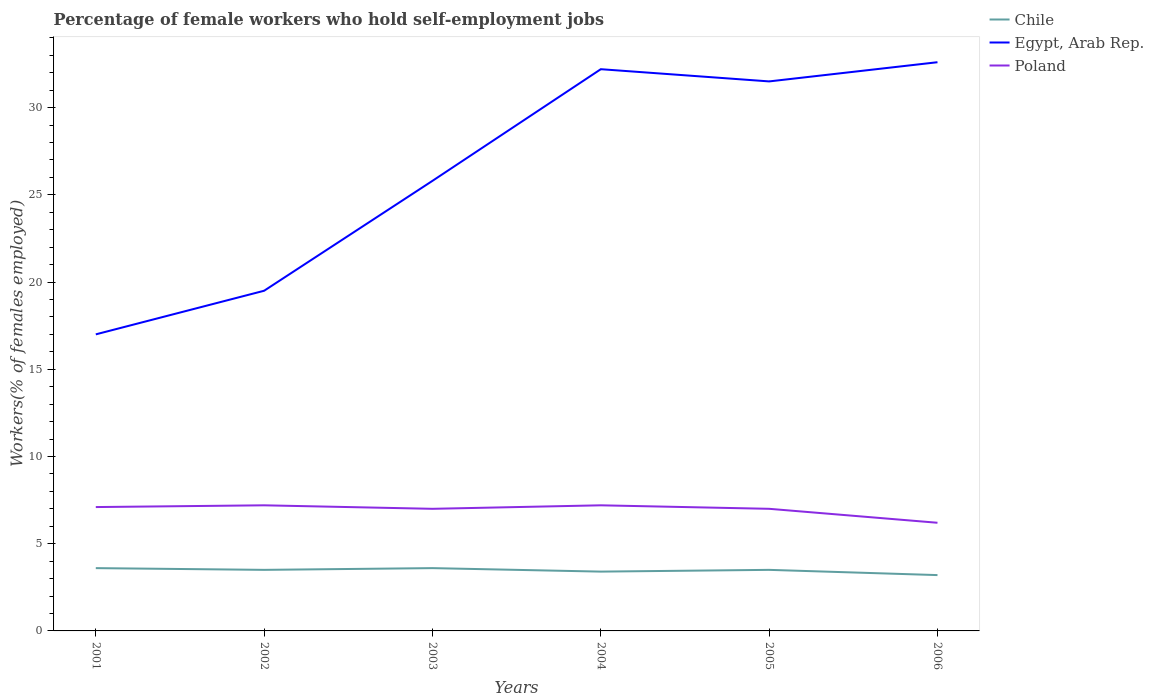How many different coloured lines are there?
Ensure brevity in your answer.  3. What is the total percentage of self-employed female workers in Egypt, Arab Rep. in the graph?
Ensure brevity in your answer.  -6.3. What is the difference between the highest and the second highest percentage of self-employed female workers in Egypt, Arab Rep.?
Provide a succinct answer. 15.6. Is the percentage of self-employed female workers in Poland strictly greater than the percentage of self-employed female workers in Chile over the years?
Give a very brief answer. No. How many lines are there?
Offer a terse response. 3. How many years are there in the graph?
Your answer should be very brief. 6. Are the values on the major ticks of Y-axis written in scientific E-notation?
Your answer should be very brief. No. Does the graph contain any zero values?
Offer a terse response. No. How are the legend labels stacked?
Your response must be concise. Vertical. What is the title of the graph?
Your answer should be compact. Percentage of female workers who hold self-employment jobs. Does "Czech Republic" appear as one of the legend labels in the graph?
Keep it short and to the point. No. What is the label or title of the Y-axis?
Your answer should be very brief. Workers(% of females employed). What is the Workers(% of females employed) in Chile in 2001?
Offer a terse response. 3.6. What is the Workers(% of females employed) of Egypt, Arab Rep. in 2001?
Give a very brief answer. 17. What is the Workers(% of females employed) of Poland in 2001?
Provide a succinct answer. 7.1. What is the Workers(% of females employed) of Chile in 2002?
Offer a very short reply. 3.5. What is the Workers(% of females employed) of Poland in 2002?
Provide a short and direct response. 7.2. What is the Workers(% of females employed) in Chile in 2003?
Your response must be concise. 3.6. What is the Workers(% of females employed) in Egypt, Arab Rep. in 2003?
Give a very brief answer. 25.8. What is the Workers(% of females employed) of Poland in 2003?
Offer a terse response. 7. What is the Workers(% of females employed) in Chile in 2004?
Your response must be concise. 3.4. What is the Workers(% of females employed) in Egypt, Arab Rep. in 2004?
Your answer should be very brief. 32.2. What is the Workers(% of females employed) of Poland in 2004?
Provide a short and direct response. 7.2. What is the Workers(% of females employed) in Chile in 2005?
Offer a very short reply. 3.5. What is the Workers(% of females employed) in Egypt, Arab Rep. in 2005?
Give a very brief answer. 31.5. What is the Workers(% of females employed) of Poland in 2005?
Your answer should be very brief. 7. What is the Workers(% of females employed) in Chile in 2006?
Your answer should be compact. 3.2. What is the Workers(% of females employed) of Egypt, Arab Rep. in 2006?
Your response must be concise. 32.6. What is the Workers(% of females employed) in Poland in 2006?
Make the answer very short. 6.2. Across all years, what is the maximum Workers(% of females employed) in Chile?
Make the answer very short. 3.6. Across all years, what is the maximum Workers(% of females employed) of Egypt, Arab Rep.?
Your answer should be very brief. 32.6. Across all years, what is the maximum Workers(% of females employed) in Poland?
Ensure brevity in your answer.  7.2. Across all years, what is the minimum Workers(% of females employed) in Chile?
Provide a succinct answer. 3.2. Across all years, what is the minimum Workers(% of females employed) in Egypt, Arab Rep.?
Give a very brief answer. 17. Across all years, what is the minimum Workers(% of females employed) of Poland?
Give a very brief answer. 6.2. What is the total Workers(% of females employed) in Chile in the graph?
Give a very brief answer. 20.8. What is the total Workers(% of females employed) in Egypt, Arab Rep. in the graph?
Give a very brief answer. 158.6. What is the total Workers(% of females employed) of Poland in the graph?
Offer a terse response. 41.7. What is the difference between the Workers(% of females employed) of Egypt, Arab Rep. in 2001 and that in 2004?
Your answer should be compact. -15.2. What is the difference between the Workers(% of females employed) of Poland in 2001 and that in 2004?
Keep it short and to the point. -0.1. What is the difference between the Workers(% of females employed) of Egypt, Arab Rep. in 2001 and that in 2005?
Provide a short and direct response. -14.5. What is the difference between the Workers(% of females employed) of Chile in 2001 and that in 2006?
Make the answer very short. 0.4. What is the difference between the Workers(% of females employed) of Egypt, Arab Rep. in 2001 and that in 2006?
Your answer should be compact. -15.6. What is the difference between the Workers(% of females employed) of Poland in 2001 and that in 2006?
Your answer should be very brief. 0.9. What is the difference between the Workers(% of females employed) in Chile in 2002 and that in 2003?
Provide a short and direct response. -0.1. What is the difference between the Workers(% of females employed) in Poland in 2002 and that in 2003?
Your response must be concise. 0.2. What is the difference between the Workers(% of females employed) in Chile in 2002 and that in 2004?
Your response must be concise. 0.1. What is the difference between the Workers(% of females employed) of Egypt, Arab Rep. in 2002 and that in 2004?
Give a very brief answer. -12.7. What is the difference between the Workers(% of females employed) of Poland in 2002 and that in 2006?
Give a very brief answer. 1. What is the difference between the Workers(% of females employed) in Poland in 2003 and that in 2004?
Your response must be concise. -0.2. What is the difference between the Workers(% of females employed) of Egypt, Arab Rep. in 2003 and that in 2005?
Provide a short and direct response. -5.7. What is the difference between the Workers(% of females employed) of Chile in 2003 and that in 2006?
Offer a terse response. 0.4. What is the difference between the Workers(% of females employed) in Poland in 2003 and that in 2006?
Your answer should be compact. 0.8. What is the difference between the Workers(% of females employed) in Poland in 2004 and that in 2005?
Offer a very short reply. 0.2. What is the difference between the Workers(% of females employed) of Egypt, Arab Rep. in 2004 and that in 2006?
Ensure brevity in your answer.  -0.4. What is the difference between the Workers(% of females employed) in Poland in 2004 and that in 2006?
Keep it short and to the point. 1. What is the difference between the Workers(% of females employed) in Poland in 2005 and that in 2006?
Your answer should be very brief. 0.8. What is the difference between the Workers(% of females employed) of Chile in 2001 and the Workers(% of females employed) of Egypt, Arab Rep. in 2002?
Provide a short and direct response. -15.9. What is the difference between the Workers(% of females employed) of Egypt, Arab Rep. in 2001 and the Workers(% of females employed) of Poland in 2002?
Your answer should be very brief. 9.8. What is the difference between the Workers(% of females employed) of Chile in 2001 and the Workers(% of females employed) of Egypt, Arab Rep. in 2003?
Make the answer very short. -22.2. What is the difference between the Workers(% of females employed) of Chile in 2001 and the Workers(% of females employed) of Egypt, Arab Rep. in 2004?
Make the answer very short. -28.6. What is the difference between the Workers(% of females employed) of Egypt, Arab Rep. in 2001 and the Workers(% of females employed) of Poland in 2004?
Keep it short and to the point. 9.8. What is the difference between the Workers(% of females employed) of Chile in 2001 and the Workers(% of females employed) of Egypt, Arab Rep. in 2005?
Your answer should be compact. -27.9. What is the difference between the Workers(% of females employed) of Chile in 2001 and the Workers(% of females employed) of Poland in 2005?
Provide a succinct answer. -3.4. What is the difference between the Workers(% of females employed) of Egypt, Arab Rep. in 2001 and the Workers(% of females employed) of Poland in 2005?
Your answer should be compact. 10. What is the difference between the Workers(% of females employed) in Chile in 2001 and the Workers(% of females employed) in Egypt, Arab Rep. in 2006?
Make the answer very short. -29. What is the difference between the Workers(% of females employed) in Egypt, Arab Rep. in 2001 and the Workers(% of females employed) in Poland in 2006?
Your answer should be very brief. 10.8. What is the difference between the Workers(% of females employed) in Chile in 2002 and the Workers(% of females employed) in Egypt, Arab Rep. in 2003?
Give a very brief answer. -22.3. What is the difference between the Workers(% of females employed) of Chile in 2002 and the Workers(% of females employed) of Poland in 2003?
Make the answer very short. -3.5. What is the difference between the Workers(% of females employed) in Egypt, Arab Rep. in 2002 and the Workers(% of females employed) in Poland in 2003?
Offer a terse response. 12.5. What is the difference between the Workers(% of females employed) of Chile in 2002 and the Workers(% of females employed) of Egypt, Arab Rep. in 2004?
Offer a terse response. -28.7. What is the difference between the Workers(% of females employed) in Egypt, Arab Rep. in 2002 and the Workers(% of females employed) in Poland in 2004?
Your response must be concise. 12.3. What is the difference between the Workers(% of females employed) of Chile in 2002 and the Workers(% of females employed) of Egypt, Arab Rep. in 2005?
Your response must be concise. -28. What is the difference between the Workers(% of females employed) of Chile in 2002 and the Workers(% of females employed) of Poland in 2005?
Your answer should be compact. -3.5. What is the difference between the Workers(% of females employed) in Egypt, Arab Rep. in 2002 and the Workers(% of females employed) in Poland in 2005?
Make the answer very short. 12.5. What is the difference between the Workers(% of females employed) of Chile in 2002 and the Workers(% of females employed) of Egypt, Arab Rep. in 2006?
Provide a short and direct response. -29.1. What is the difference between the Workers(% of females employed) of Chile in 2002 and the Workers(% of females employed) of Poland in 2006?
Provide a short and direct response. -2.7. What is the difference between the Workers(% of females employed) in Chile in 2003 and the Workers(% of females employed) in Egypt, Arab Rep. in 2004?
Offer a terse response. -28.6. What is the difference between the Workers(% of females employed) of Chile in 2003 and the Workers(% of females employed) of Poland in 2004?
Provide a short and direct response. -3.6. What is the difference between the Workers(% of females employed) of Egypt, Arab Rep. in 2003 and the Workers(% of females employed) of Poland in 2004?
Ensure brevity in your answer.  18.6. What is the difference between the Workers(% of females employed) in Chile in 2003 and the Workers(% of females employed) in Egypt, Arab Rep. in 2005?
Make the answer very short. -27.9. What is the difference between the Workers(% of females employed) in Chile in 2003 and the Workers(% of females employed) in Poland in 2005?
Keep it short and to the point. -3.4. What is the difference between the Workers(% of females employed) of Egypt, Arab Rep. in 2003 and the Workers(% of females employed) of Poland in 2005?
Provide a succinct answer. 18.8. What is the difference between the Workers(% of females employed) in Chile in 2003 and the Workers(% of females employed) in Egypt, Arab Rep. in 2006?
Provide a short and direct response. -29. What is the difference between the Workers(% of females employed) in Chile in 2003 and the Workers(% of females employed) in Poland in 2006?
Your answer should be compact. -2.6. What is the difference between the Workers(% of females employed) of Egypt, Arab Rep. in 2003 and the Workers(% of females employed) of Poland in 2006?
Your answer should be very brief. 19.6. What is the difference between the Workers(% of females employed) in Chile in 2004 and the Workers(% of females employed) in Egypt, Arab Rep. in 2005?
Offer a very short reply. -28.1. What is the difference between the Workers(% of females employed) in Egypt, Arab Rep. in 2004 and the Workers(% of females employed) in Poland in 2005?
Offer a very short reply. 25.2. What is the difference between the Workers(% of females employed) of Chile in 2004 and the Workers(% of females employed) of Egypt, Arab Rep. in 2006?
Your answer should be very brief. -29.2. What is the difference between the Workers(% of females employed) in Chile in 2004 and the Workers(% of females employed) in Poland in 2006?
Keep it short and to the point. -2.8. What is the difference between the Workers(% of females employed) of Chile in 2005 and the Workers(% of females employed) of Egypt, Arab Rep. in 2006?
Provide a succinct answer. -29.1. What is the difference between the Workers(% of females employed) in Chile in 2005 and the Workers(% of females employed) in Poland in 2006?
Offer a terse response. -2.7. What is the difference between the Workers(% of females employed) of Egypt, Arab Rep. in 2005 and the Workers(% of females employed) of Poland in 2006?
Keep it short and to the point. 25.3. What is the average Workers(% of females employed) in Chile per year?
Your response must be concise. 3.47. What is the average Workers(% of females employed) in Egypt, Arab Rep. per year?
Offer a very short reply. 26.43. What is the average Workers(% of females employed) in Poland per year?
Ensure brevity in your answer.  6.95. In the year 2001, what is the difference between the Workers(% of females employed) in Chile and Workers(% of females employed) in Poland?
Offer a very short reply. -3.5. In the year 2001, what is the difference between the Workers(% of females employed) of Egypt, Arab Rep. and Workers(% of females employed) of Poland?
Your response must be concise. 9.9. In the year 2002, what is the difference between the Workers(% of females employed) in Chile and Workers(% of females employed) in Egypt, Arab Rep.?
Offer a terse response. -16. In the year 2002, what is the difference between the Workers(% of females employed) of Chile and Workers(% of females employed) of Poland?
Ensure brevity in your answer.  -3.7. In the year 2002, what is the difference between the Workers(% of females employed) in Egypt, Arab Rep. and Workers(% of females employed) in Poland?
Give a very brief answer. 12.3. In the year 2003, what is the difference between the Workers(% of females employed) in Chile and Workers(% of females employed) in Egypt, Arab Rep.?
Provide a short and direct response. -22.2. In the year 2003, what is the difference between the Workers(% of females employed) in Egypt, Arab Rep. and Workers(% of females employed) in Poland?
Your answer should be compact. 18.8. In the year 2004, what is the difference between the Workers(% of females employed) in Chile and Workers(% of females employed) in Egypt, Arab Rep.?
Your answer should be compact. -28.8. In the year 2004, what is the difference between the Workers(% of females employed) of Chile and Workers(% of females employed) of Poland?
Keep it short and to the point. -3.8. In the year 2004, what is the difference between the Workers(% of females employed) of Egypt, Arab Rep. and Workers(% of females employed) of Poland?
Your response must be concise. 25. In the year 2005, what is the difference between the Workers(% of females employed) of Chile and Workers(% of females employed) of Poland?
Ensure brevity in your answer.  -3.5. In the year 2006, what is the difference between the Workers(% of females employed) of Chile and Workers(% of females employed) of Egypt, Arab Rep.?
Your response must be concise. -29.4. In the year 2006, what is the difference between the Workers(% of females employed) in Egypt, Arab Rep. and Workers(% of females employed) in Poland?
Ensure brevity in your answer.  26.4. What is the ratio of the Workers(% of females employed) in Chile in 2001 to that in 2002?
Ensure brevity in your answer.  1.03. What is the ratio of the Workers(% of females employed) of Egypt, Arab Rep. in 2001 to that in 2002?
Provide a succinct answer. 0.87. What is the ratio of the Workers(% of females employed) in Poland in 2001 to that in 2002?
Your answer should be compact. 0.99. What is the ratio of the Workers(% of females employed) in Egypt, Arab Rep. in 2001 to that in 2003?
Offer a very short reply. 0.66. What is the ratio of the Workers(% of females employed) of Poland in 2001 to that in 2003?
Provide a short and direct response. 1.01. What is the ratio of the Workers(% of females employed) of Chile in 2001 to that in 2004?
Offer a terse response. 1.06. What is the ratio of the Workers(% of females employed) in Egypt, Arab Rep. in 2001 to that in 2004?
Give a very brief answer. 0.53. What is the ratio of the Workers(% of females employed) of Poland in 2001 to that in 2004?
Provide a short and direct response. 0.99. What is the ratio of the Workers(% of females employed) in Chile in 2001 to that in 2005?
Provide a succinct answer. 1.03. What is the ratio of the Workers(% of females employed) in Egypt, Arab Rep. in 2001 to that in 2005?
Offer a terse response. 0.54. What is the ratio of the Workers(% of females employed) in Poland in 2001 to that in 2005?
Make the answer very short. 1.01. What is the ratio of the Workers(% of females employed) of Egypt, Arab Rep. in 2001 to that in 2006?
Give a very brief answer. 0.52. What is the ratio of the Workers(% of females employed) of Poland in 2001 to that in 2006?
Give a very brief answer. 1.15. What is the ratio of the Workers(% of females employed) in Chile in 2002 to that in 2003?
Offer a very short reply. 0.97. What is the ratio of the Workers(% of females employed) in Egypt, Arab Rep. in 2002 to that in 2003?
Ensure brevity in your answer.  0.76. What is the ratio of the Workers(% of females employed) in Poland in 2002 to that in 2003?
Provide a short and direct response. 1.03. What is the ratio of the Workers(% of females employed) of Chile in 2002 to that in 2004?
Offer a very short reply. 1.03. What is the ratio of the Workers(% of females employed) of Egypt, Arab Rep. in 2002 to that in 2004?
Keep it short and to the point. 0.61. What is the ratio of the Workers(% of females employed) in Chile in 2002 to that in 2005?
Your answer should be very brief. 1. What is the ratio of the Workers(% of females employed) in Egypt, Arab Rep. in 2002 to that in 2005?
Provide a short and direct response. 0.62. What is the ratio of the Workers(% of females employed) of Poland in 2002 to that in 2005?
Offer a terse response. 1.03. What is the ratio of the Workers(% of females employed) in Chile in 2002 to that in 2006?
Give a very brief answer. 1.09. What is the ratio of the Workers(% of females employed) of Egypt, Arab Rep. in 2002 to that in 2006?
Your response must be concise. 0.6. What is the ratio of the Workers(% of females employed) of Poland in 2002 to that in 2006?
Give a very brief answer. 1.16. What is the ratio of the Workers(% of females employed) of Chile in 2003 to that in 2004?
Offer a terse response. 1.06. What is the ratio of the Workers(% of females employed) in Egypt, Arab Rep. in 2003 to that in 2004?
Offer a terse response. 0.8. What is the ratio of the Workers(% of females employed) in Poland in 2003 to that in 2004?
Provide a succinct answer. 0.97. What is the ratio of the Workers(% of females employed) in Chile in 2003 to that in 2005?
Your answer should be very brief. 1.03. What is the ratio of the Workers(% of females employed) in Egypt, Arab Rep. in 2003 to that in 2005?
Provide a succinct answer. 0.82. What is the ratio of the Workers(% of females employed) in Poland in 2003 to that in 2005?
Give a very brief answer. 1. What is the ratio of the Workers(% of females employed) of Chile in 2003 to that in 2006?
Make the answer very short. 1.12. What is the ratio of the Workers(% of females employed) in Egypt, Arab Rep. in 2003 to that in 2006?
Give a very brief answer. 0.79. What is the ratio of the Workers(% of females employed) in Poland in 2003 to that in 2006?
Keep it short and to the point. 1.13. What is the ratio of the Workers(% of females employed) in Chile in 2004 to that in 2005?
Keep it short and to the point. 0.97. What is the ratio of the Workers(% of females employed) in Egypt, Arab Rep. in 2004 to that in 2005?
Offer a very short reply. 1.02. What is the ratio of the Workers(% of females employed) of Poland in 2004 to that in 2005?
Provide a short and direct response. 1.03. What is the ratio of the Workers(% of females employed) of Chile in 2004 to that in 2006?
Offer a terse response. 1.06. What is the ratio of the Workers(% of females employed) of Egypt, Arab Rep. in 2004 to that in 2006?
Your answer should be compact. 0.99. What is the ratio of the Workers(% of females employed) of Poland in 2004 to that in 2006?
Offer a terse response. 1.16. What is the ratio of the Workers(% of females employed) of Chile in 2005 to that in 2006?
Give a very brief answer. 1.09. What is the ratio of the Workers(% of females employed) of Egypt, Arab Rep. in 2005 to that in 2006?
Your response must be concise. 0.97. What is the ratio of the Workers(% of females employed) in Poland in 2005 to that in 2006?
Make the answer very short. 1.13. What is the difference between the highest and the second highest Workers(% of females employed) of Chile?
Your response must be concise. 0. What is the difference between the highest and the second highest Workers(% of females employed) in Egypt, Arab Rep.?
Provide a short and direct response. 0.4. What is the difference between the highest and the lowest Workers(% of females employed) in Chile?
Ensure brevity in your answer.  0.4. What is the difference between the highest and the lowest Workers(% of females employed) in Egypt, Arab Rep.?
Provide a short and direct response. 15.6. What is the difference between the highest and the lowest Workers(% of females employed) in Poland?
Provide a short and direct response. 1. 